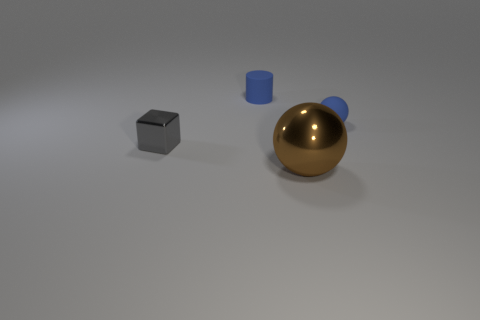There is a cylinder that is the same color as the tiny rubber sphere; what material is it?
Offer a very short reply. Rubber. Are there any other things that have the same shape as the large thing?
Your response must be concise. Yes. What material is the small object that is in front of the tiny blue rubber cylinder and to the right of the cube?
Your answer should be compact. Rubber. Is the brown object made of the same material as the object that is left of the tiny rubber cylinder?
Offer a terse response. Yes. Is there anything else that is the same size as the metal block?
Your response must be concise. Yes. What number of objects are either small metallic cubes or shiny objects on the right side of the tiny matte cylinder?
Provide a short and direct response. 2. Does the ball left of the small blue rubber ball have the same size as the ball behind the gray metal thing?
Make the answer very short. No. What number of other objects are there of the same color as the big shiny thing?
Offer a very short reply. 0. There is a brown ball; does it have the same size as the blue thing that is to the left of the small blue rubber sphere?
Give a very brief answer. No. What is the size of the blue object left of the ball that is behind the tiny shiny object?
Your answer should be compact. Small. 